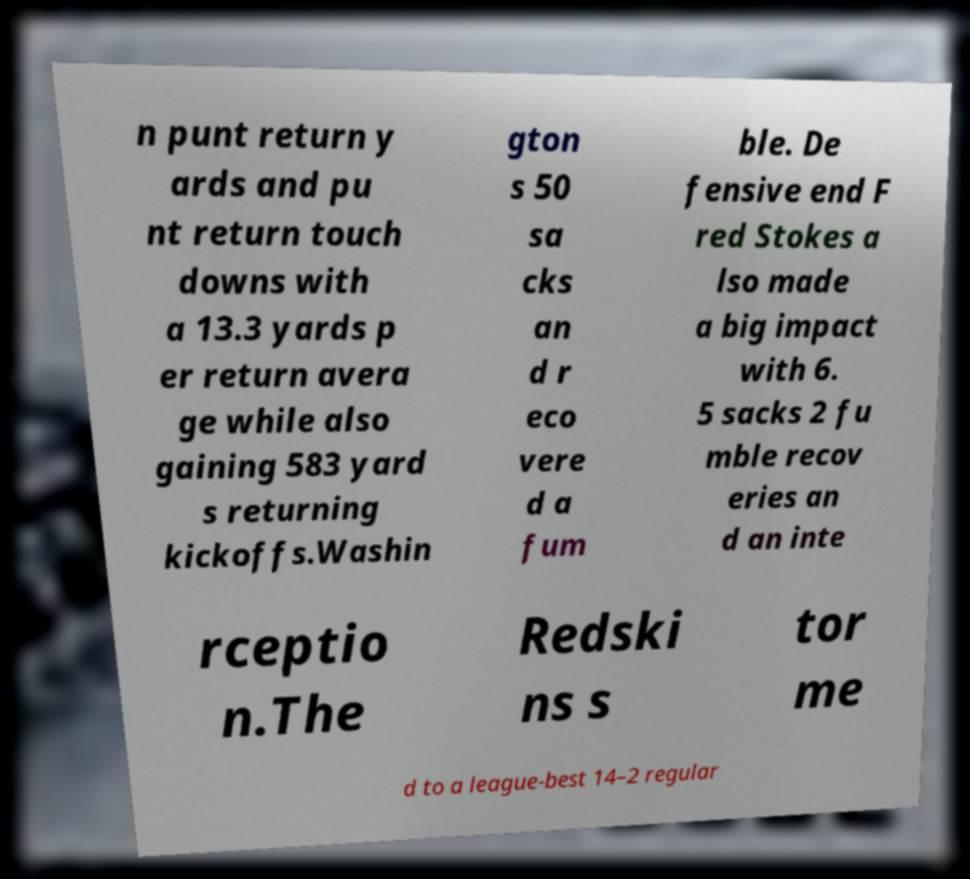Can you accurately transcribe the text from the provided image for me? n punt return y ards and pu nt return touch downs with a 13.3 yards p er return avera ge while also gaining 583 yard s returning kickoffs.Washin gton s 50 sa cks an d r eco vere d a fum ble. De fensive end F red Stokes a lso made a big impact with 6. 5 sacks 2 fu mble recov eries an d an inte rceptio n.The Redski ns s tor me d to a league-best 14–2 regular 